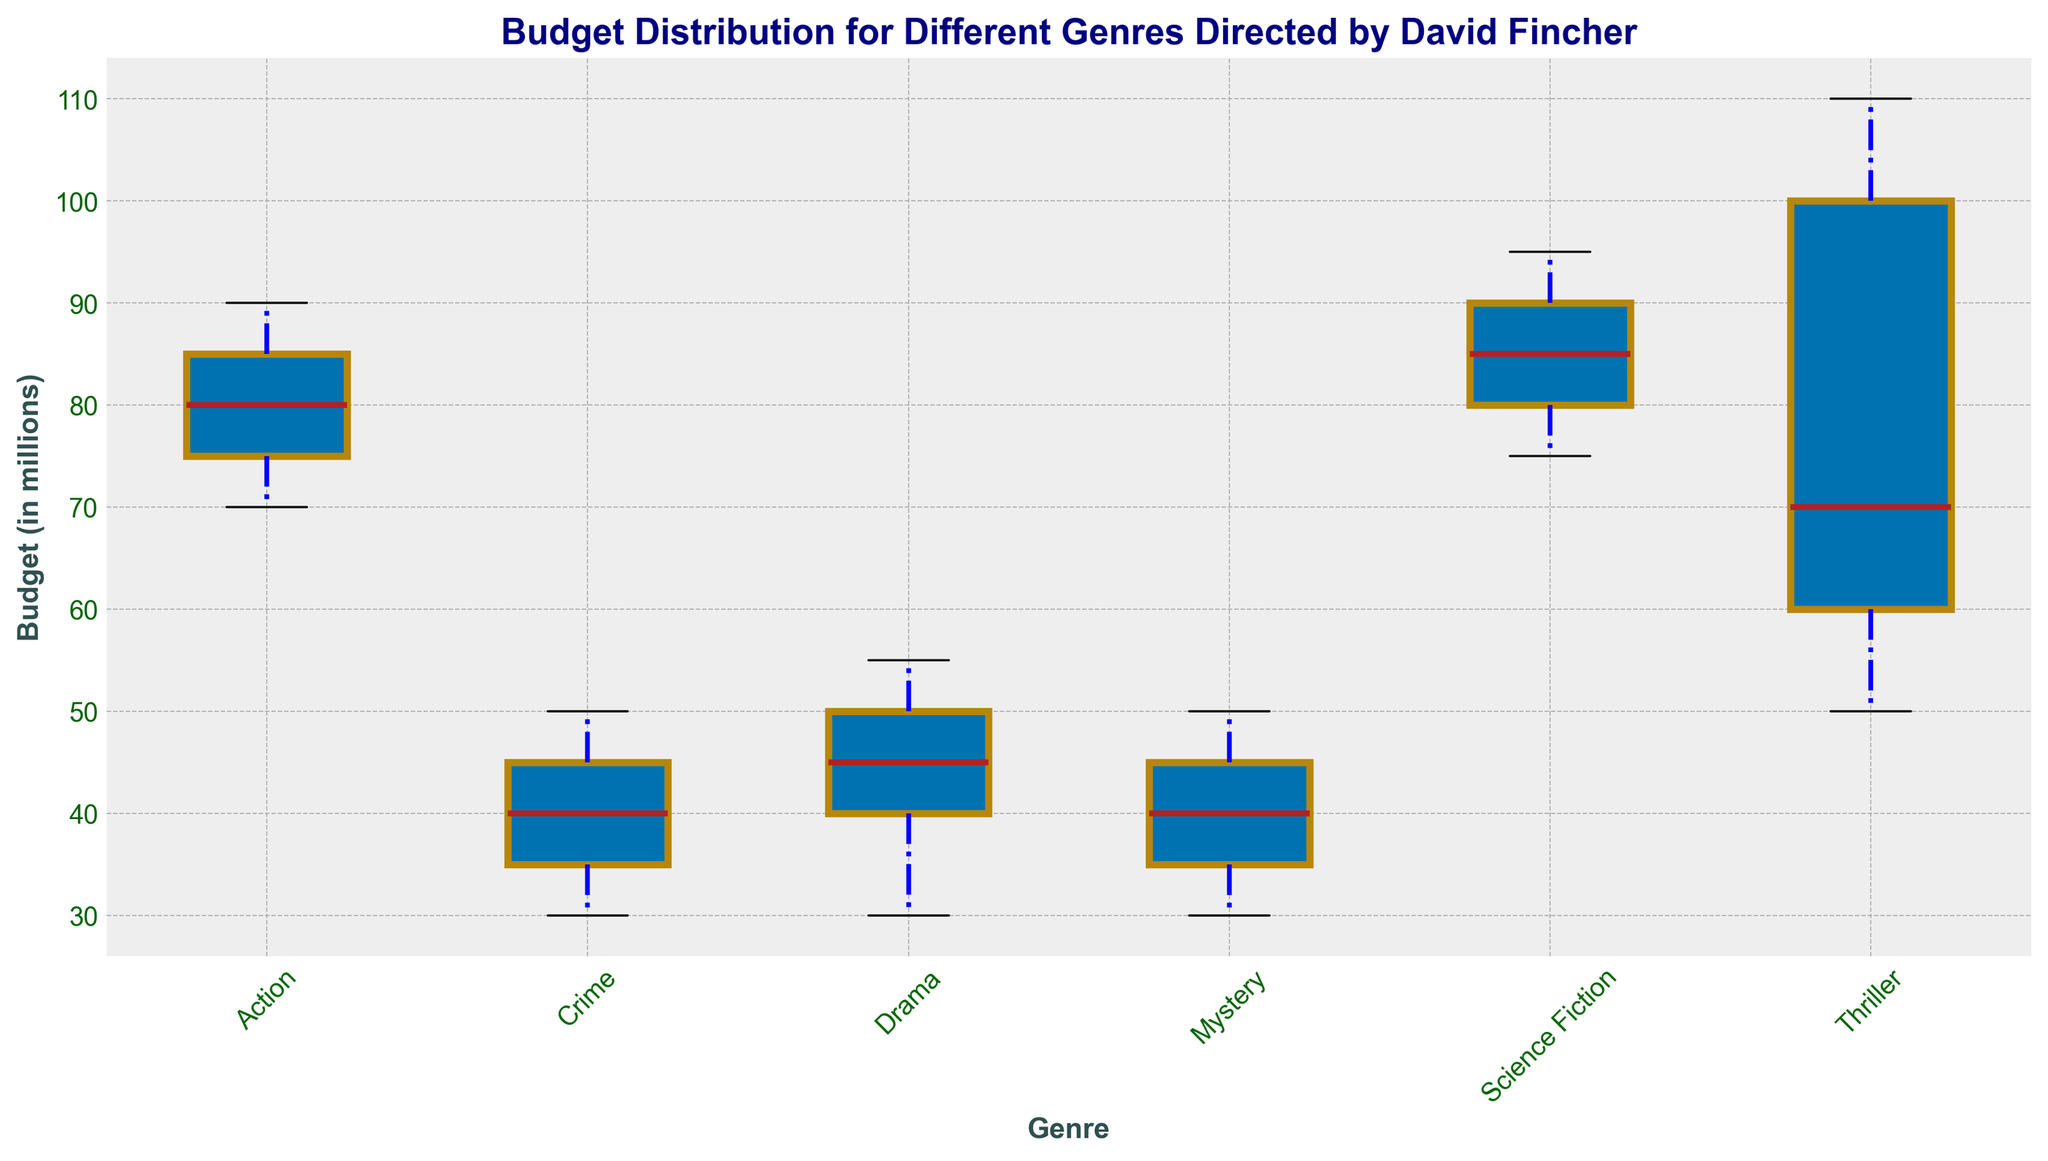What's the median budget for the Thriller genre? The median budget for the Thriller genre is found by identifying the middle value from the ordered budgets. Ordering: [50, 60, 70, 100, 110], we get the median as the middle value, which is 70.
Answer: 70 Which genre has the highest median budget? Comparing the central line (median) on the box plots for each genre, the Science Fiction genre has the highest median budget.
Answer: Science Fiction What is the range of budgets for the Action genre? Range is calculated by subtracting the smallest value (lower whisker) from the largest value (upper whisker). For the Action genre, the range is 90 - 70 = 20.
Answer: 20 How does the interquartile range (IQR) of the Drama genre compare to that of the Crime genre? The IQR is the difference between the upper quartile (Q3) and the lower quartile (Q1). For Drama, Q3 is around 50 and Q1 is around 40, so IQR = 50 - 40 = 10. For Crime, Q3 is around 45 and Q1 is around 35, so IQR = 45 - 35 = 10. The IQRs of Drama and Crime are equal.
Answer: Equal Which genre has the smallest range of budgets? The range is the difference between the max and min budget shown by the whiskers. By visual inspection, both the Mystery and Drama genres appear to have smaller ranges compared to others. Reassessing, Drama ranges from 55 to 30 (25) and Mystery from 50 to 30 (20), thus Mystery has the smallest range.
Answer: Mystery Is there any genre with no outliers in its budget distribution? Outliers are typically marked as individual points outside the whiskers. By observing the box plots, all genres seem to have no marked outliers within the whiskers, since no outliers are shown as points outside of the respective whiskers.
Answer: All genres have no outliers How does the maximum budget of the Thriller genre compare to the minimum budget of the Science Fiction genre? The maximum budget for the Thriller genre is 110 million, and the minimum budget for the Science Fiction genre is 75 million. Comparing 110 to 75 shows that the maximum budget for the Thriller genre is higher.
Answer: Higher By how much does the median budget of the Science Fiction genre exceed that of the Mystery genre? The median value for Science Fiction is 85, while for Mystery it is 40. Subtracting these, 85 - 40 = 45, the median budget for the Science Fiction genre exceeds the Mystery genre by 45 million.
Answer: 45 million Which genre has the highest variation in budget? Variation can be estimated by range and the spread of the box. By observing the lengths of the boxes and whiskers, the Thriller genre shows the widest spread from 50 to 110, indicating the highest variation.
Answer: Thriller What is the mid-range budget for the Crime genre? Mid-range is calculated by averaging the minimum and maximum values. For the Crime genre, this is (30 + 50) / 2 = 40.
Answer: 40 